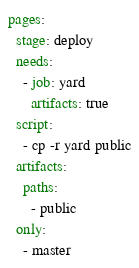Convert code to text. <code><loc_0><loc_0><loc_500><loc_500><_YAML_>pages:
  stage: deploy
  needs:
    - job: yard
      artifacts: true
  script:
    - cp -r yard public
  artifacts:
    paths:
      - public
  only:
    - master
</code> 